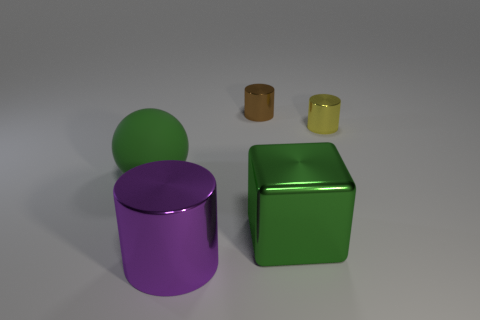There is a shiny cube that is the same color as the large sphere; what size is it?
Your answer should be very brief. Large. There is a small metal thing that is right of the brown metallic object; what number of large green objects are in front of it?
Offer a terse response. 2. How many other objects are there of the same size as the block?
Give a very brief answer. 2. Is the color of the matte object the same as the big cube?
Provide a short and direct response. Yes. Is the shape of the thing that is behind the small yellow cylinder the same as  the large green metallic object?
Provide a succinct answer. No. What number of cylinders are in front of the yellow cylinder and behind the yellow metal object?
Your response must be concise. 0. What is the large purple object made of?
Give a very brief answer. Metal. Are there any other things that have the same color as the large rubber sphere?
Your answer should be very brief. Yes. Is the brown cylinder made of the same material as the yellow object?
Offer a very short reply. Yes. How many cylinders are on the right side of the tiny thing that is to the left of the small cylinder right of the large green metallic thing?
Your answer should be very brief. 1. 